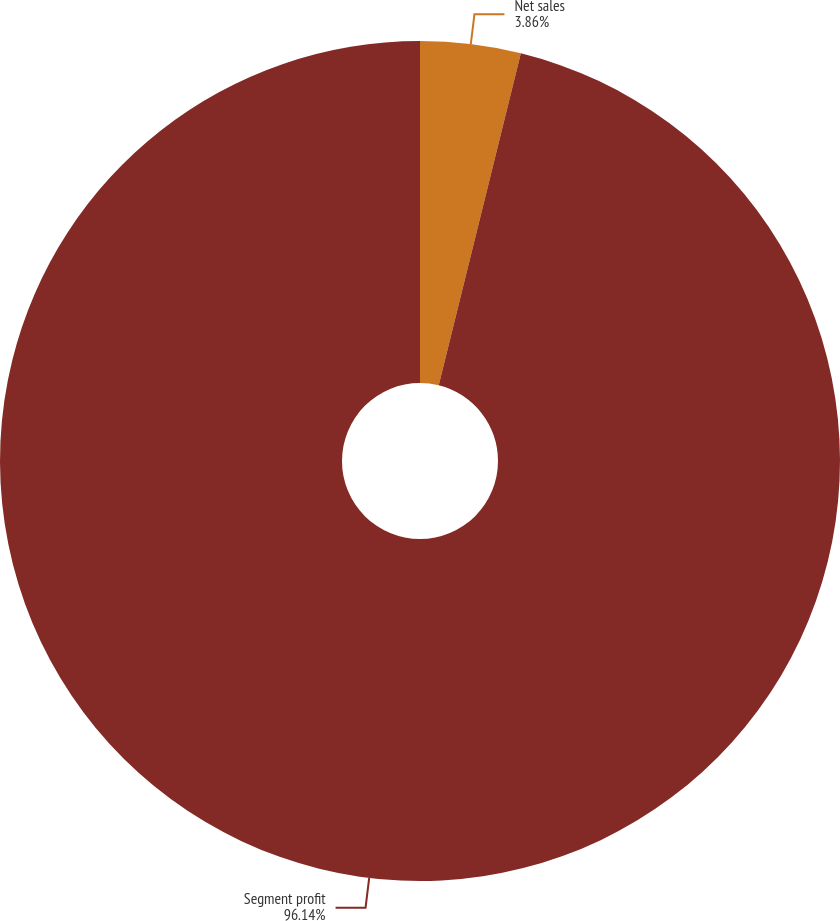Convert chart. <chart><loc_0><loc_0><loc_500><loc_500><pie_chart><fcel>Net sales<fcel>Segment profit<nl><fcel>3.86%<fcel>96.14%<nl></chart> 